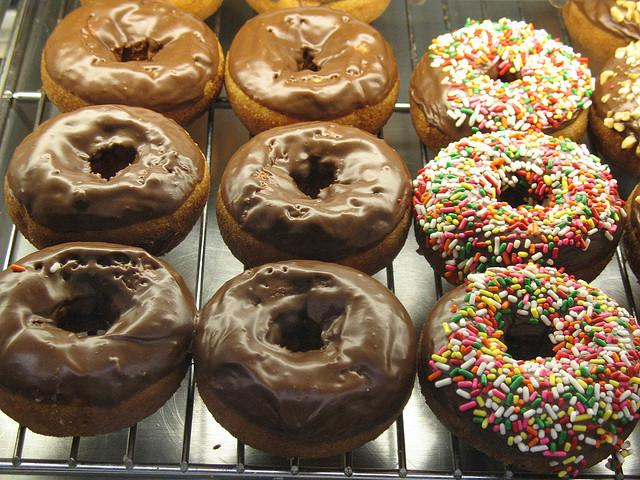These items are usually eaten for what?

Choices:
A) lunch
B) snack
C) fancy wedding
D) dinner snack 